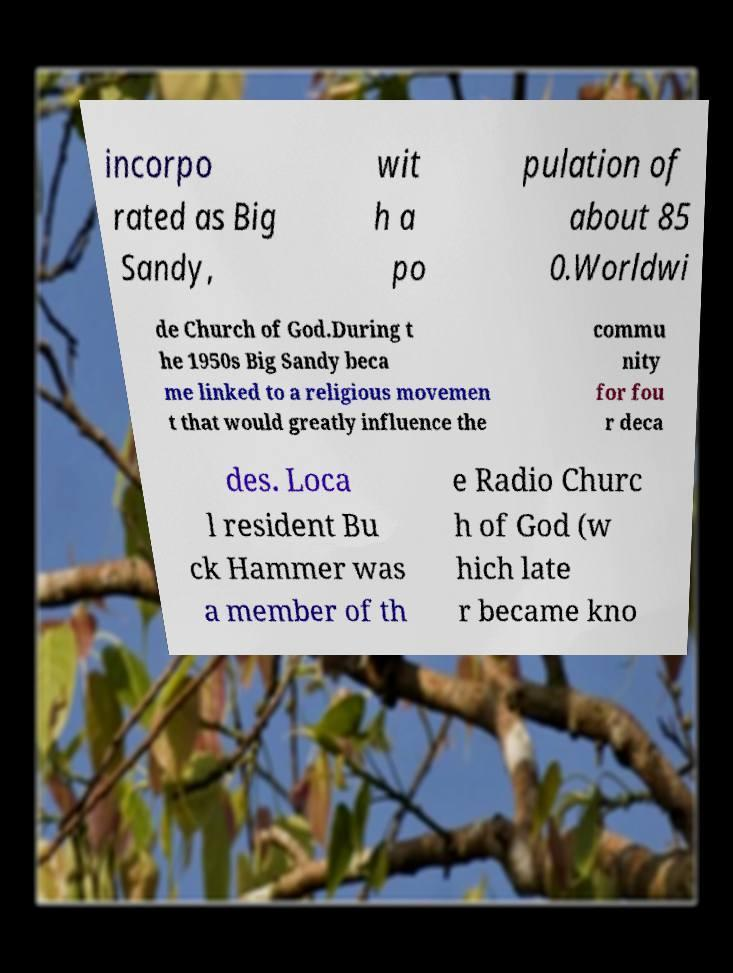Please read and relay the text visible in this image. What does it say? incorpo rated as Big Sandy, wit h a po pulation of about 85 0.Worldwi de Church of God.During t he 1950s Big Sandy beca me linked to a religious movemen t that would greatly influence the commu nity for fou r deca des. Loca l resident Bu ck Hammer was a member of th e Radio Churc h of God (w hich late r became kno 